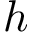<formula> <loc_0><loc_0><loc_500><loc_500>h</formula> 